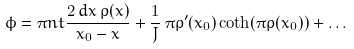<formula> <loc_0><loc_0><loc_500><loc_500>\phi = \pi n t \frac { 2 \, d x \, \rho ( x ) } { x _ { 0 } - x } + \frac { 1 } { J } \, \pi \rho ^ { \prime } ( x _ { 0 } ) \coth ( \pi \rho ( x _ { 0 } ) ) + \dots</formula> 